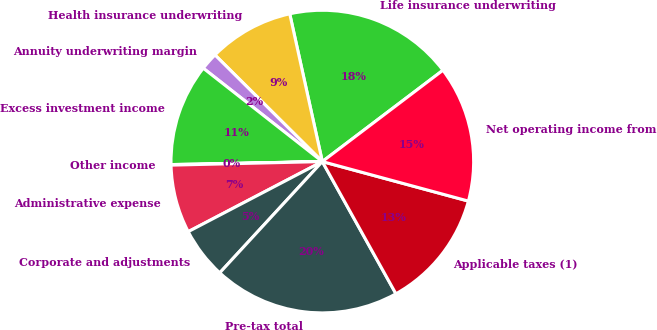Convert chart to OTSL. <chart><loc_0><loc_0><loc_500><loc_500><pie_chart><fcel>Life insurance underwriting<fcel>Health insurance underwriting<fcel>Annuity underwriting margin<fcel>Excess investment income<fcel>Other income<fcel>Administrative expense<fcel>Corporate and adjustments<fcel>Pre-tax total<fcel>Applicable taxes (1)<fcel>Net operating income from<nl><fcel>18.14%<fcel>9.1%<fcel>1.86%<fcel>10.9%<fcel>0.06%<fcel>7.29%<fcel>5.48%<fcel>19.94%<fcel>12.71%<fcel>14.52%<nl></chart> 